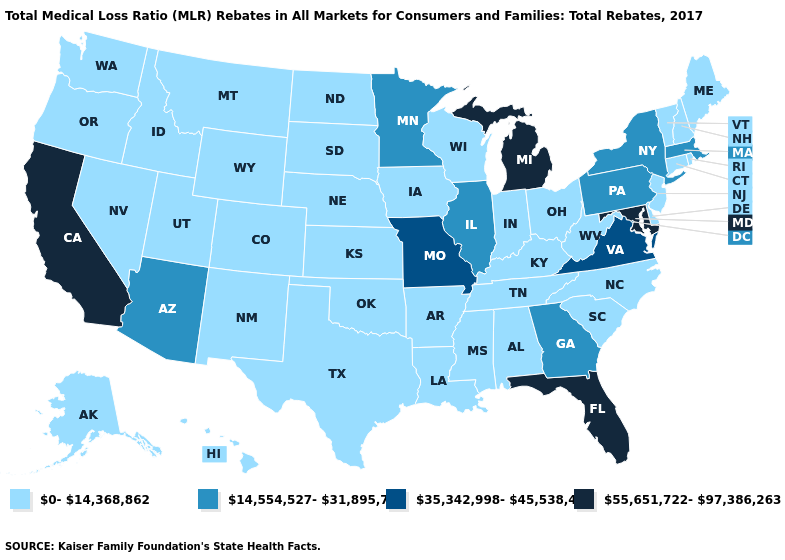Name the states that have a value in the range 0-14,368,862?
Answer briefly. Alabama, Alaska, Arkansas, Colorado, Connecticut, Delaware, Hawaii, Idaho, Indiana, Iowa, Kansas, Kentucky, Louisiana, Maine, Mississippi, Montana, Nebraska, Nevada, New Hampshire, New Jersey, New Mexico, North Carolina, North Dakota, Ohio, Oklahoma, Oregon, Rhode Island, South Carolina, South Dakota, Tennessee, Texas, Utah, Vermont, Washington, West Virginia, Wisconsin, Wyoming. Which states hav the highest value in the Northeast?
Concise answer only. Massachusetts, New York, Pennsylvania. What is the value of West Virginia?
Quick response, please. 0-14,368,862. What is the value of Kentucky?
Short answer required. 0-14,368,862. Name the states that have a value in the range 14,554,527-31,895,756?
Write a very short answer. Arizona, Georgia, Illinois, Massachusetts, Minnesota, New York, Pennsylvania. What is the value of South Carolina?
Give a very brief answer. 0-14,368,862. Which states have the lowest value in the West?
Keep it brief. Alaska, Colorado, Hawaii, Idaho, Montana, Nevada, New Mexico, Oregon, Utah, Washington, Wyoming. What is the lowest value in the West?
Write a very short answer. 0-14,368,862. Does Missouri have the lowest value in the MidWest?
Be succinct. No. What is the highest value in states that border Nebraska?
Be succinct. 35,342,998-45,538,433. Does Arkansas have a lower value than New Hampshire?
Short answer required. No. Which states have the highest value in the USA?
Short answer required. California, Florida, Maryland, Michigan. Does Rhode Island have the highest value in the Northeast?
Keep it brief. No. Which states have the lowest value in the South?
Write a very short answer. Alabama, Arkansas, Delaware, Kentucky, Louisiana, Mississippi, North Carolina, Oklahoma, South Carolina, Tennessee, Texas, West Virginia. Which states hav the highest value in the South?
Short answer required. Florida, Maryland. 